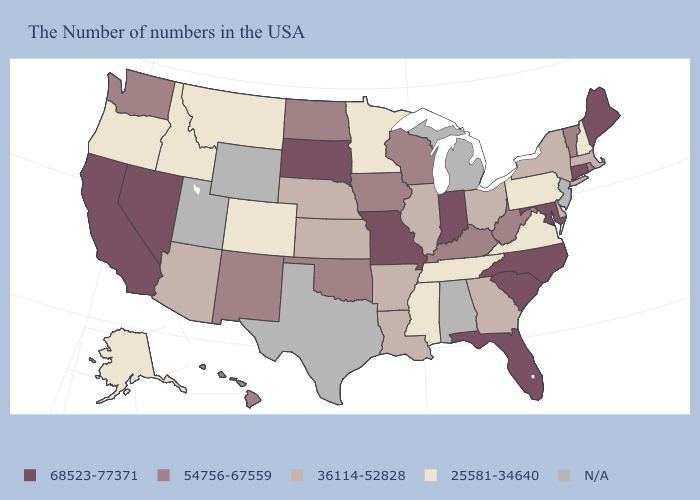What is the highest value in the Northeast ?
Concise answer only. 68523-77371. Name the states that have a value in the range 36114-52828?
Give a very brief answer. Massachusetts, New York, Delaware, Ohio, Georgia, Illinois, Louisiana, Arkansas, Kansas, Nebraska, Arizona. Which states have the highest value in the USA?
Short answer required. Maine, Connecticut, Maryland, North Carolina, South Carolina, Florida, Indiana, Missouri, South Dakota, Nevada, California. Name the states that have a value in the range 25581-34640?
Short answer required. New Hampshire, Pennsylvania, Virginia, Tennessee, Mississippi, Minnesota, Colorado, Montana, Idaho, Oregon, Alaska. Which states hav the highest value in the MidWest?
Quick response, please. Indiana, Missouri, South Dakota. Which states have the lowest value in the USA?
Concise answer only. New Hampshire, Pennsylvania, Virginia, Tennessee, Mississippi, Minnesota, Colorado, Montana, Idaho, Oregon, Alaska. Which states hav the highest value in the Northeast?
Answer briefly. Maine, Connecticut. Name the states that have a value in the range 36114-52828?
Give a very brief answer. Massachusetts, New York, Delaware, Ohio, Georgia, Illinois, Louisiana, Arkansas, Kansas, Nebraska, Arizona. Name the states that have a value in the range 54756-67559?
Give a very brief answer. Rhode Island, Vermont, West Virginia, Kentucky, Wisconsin, Iowa, Oklahoma, North Dakota, New Mexico, Washington, Hawaii. What is the lowest value in the USA?
Concise answer only. 25581-34640. What is the value of Indiana?
Concise answer only. 68523-77371. Which states have the lowest value in the USA?
Be succinct. New Hampshire, Pennsylvania, Virginia, Tennessee, Mississippi, Minnesota, Colorado, Montana, Idaho, Oregon, Alaska. What is the lowest value in the West?
Be succinct. 25581-34640. Which states have the lowest value in the USA?
Quick response, please. New Hampshire, Pennsylvania, Virginia, Tennessee, Mississippi, Minnesota, Colorado, Montana, Idaho, Oregon, Alaska. How many symbols are there in the legend?
Write a very short answer. 5. 